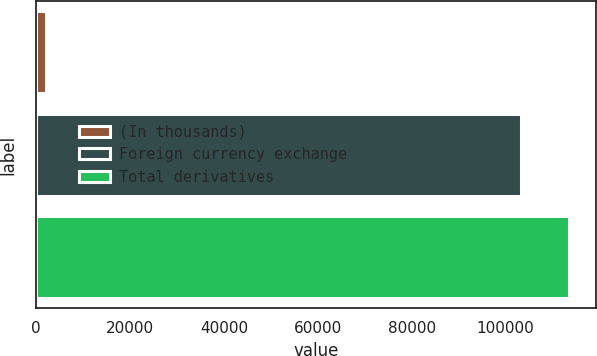<chart> <loc_0><loc_0><loc_500><loc_500><bar_chart><fcel>(In thousands)<fcel>Foreign currency exchange<fcel>Total derivatives<nl><fcel>2016<fcel>103340<fcel>113472<nl></chart> 